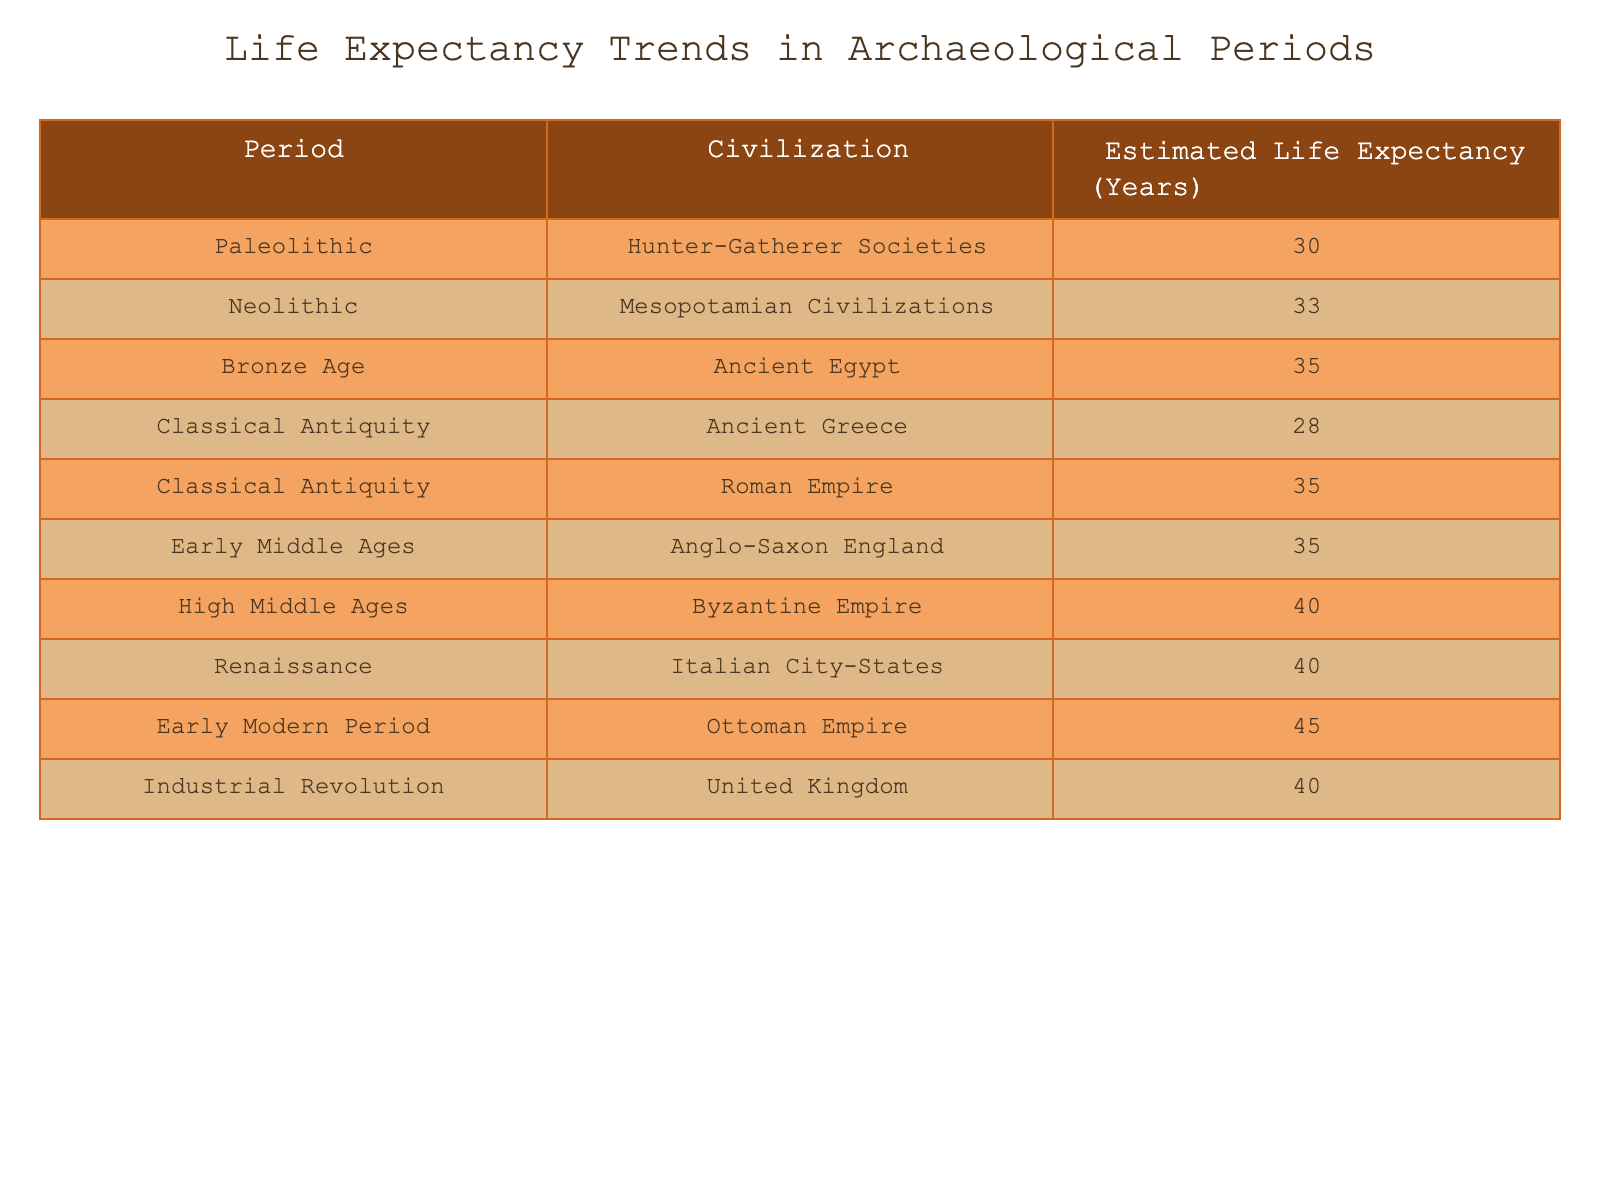What is the estimated life expectancy during the Renaissance? According to the table, the estimated life expectancy during the Renaissance period in the Italian City-States is reported as 40 years.
Answer: 40 Which civilization had the highest estimated life expectancy during the table's periods? The table shows that during the Early Modern Period, the Ottoman Empire had the highest estimated life expectancy of 45 years.
Answer: 45 What is the difference in life expectancy between the High Middle Ages and the Early Modern Period? The High Middle Ages had a life expectancy of 40 years, while the Early Modern Period had 45 years. Therefore, the difference is 45 - 40 = 5 years.
Answer: 5 True or False: The life expectancy in Ancient Greece is higher than that in the Byzantine Empire. The estimated life expectancy in Ancient Greece during Classical Antiquity is 28 years, compared to 40 years in the Byzantine Empire during the High Middle Ages. Thus, the statement is false.
Answer: False What is the average life expectancy from the Classical Antiquity period? The table lists two life expectancies for Classical Antiquity: Ancient Greece (28 years) and Roman Empire (35 years). The average is calculated as (28 + 35) / 2 = 31.5 years.
Answer: 31.5 How much did life expectancy increase from the Paleolithic to the High Middle Ages? The Paleolithic period has an estimated life expectancy of 30 years and the High Middle Ages has 40 years. The increase is calculated as 40 - 30 = 10 years.
Answer: 10 Which period had a life expectancy of 35 years, and how many civilizations were in this category? The table indicates that two periods had a life expectancy of 35 years: the Bronze Age (Ancient Egypt) and the Early Middle Ages (Anglo-Saxon England), making a total of two civilizations.
Answer: 2 True or False: The life expectancy during the Industrial Revolution was less than that of the Renaissance. According to the table, the life expectancy during the Industrial Revolution in the United Kingdom is 40 years, which is equal to that during the Renaissance in the Italian City-States (also 40 years). Therefore, the statement is false.
Answer: False 